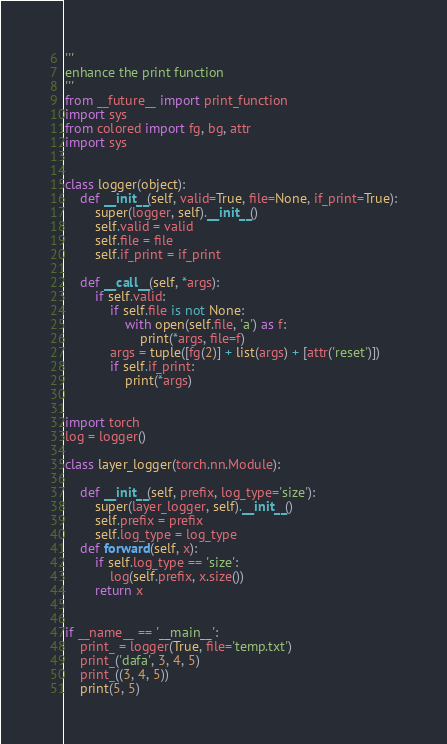<code> <loc_0><loc_0><loc_500><loc_500><_Python_>'''
enhance the print function
'''
from __future__ import print_function
import sys
from colored import fg, bg, attr
import sys


class logger(object):
    def __init__(self, valid=True, file=None, if_print=True):
        super(logger, self).__init__()
        self.valid = valid
        self.file = file
        self.if_print = if_print

    def __call__(self, *args):
        if self.valid:
            if self.file is not None:
                with open(self.file, 'a') as f:
                    print(*args, file=f)
            args = tuple([fg(2)] + list(args) + [attr('reset')])
            if self.if_print:
                print(*args)


import torch
log = logger()

class layer_logger(torch.nn.Module):

    def __init__(self, prefix, log_type='size'):
        super(layer_logger, self).__init__()
        self.prefix = prefix
        self.log_type = log_type
    def forward(self, x):
        if self.log_type == 'size':
            log(self.prefix, x.size())
        return x


if __name__ == '__main__':
    print_ = logger(True, file='temp.txt')
    print_('dafa', 3, 4, 5)
    print_((3, 4, 5))
    print(5, 5)
</code> 